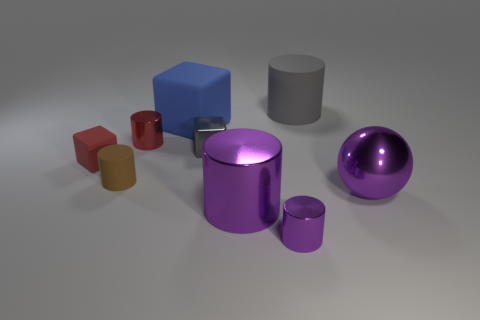There is a big shiny thing that is the same color as the large metallic cylinder; what shape is it?
Keep it short and to the point. Sphere. There is a ball that is the same color as the large shiny cylinder; what size is it?
Your answer should be compact. Large. What number of rubber things have the same color as the large sphere?
Ensure brevity in your answer.  0. There is a purple thing that is the same size as the gray metallic thing; what is its material?
Your answer should be compact. Metal. Are there any big gray rubber cylinders that are left of the block on the left side of the large blue object?
Ensure brevity in your answer.  No. What number of other things are the same color as the big cube?
Your answer should be compact. 0. How big is the gray matte cylinder?
Ensure brevity in your answer.  Large. Are there any big cyan matte things?
Your answer should be compact. No. Are there more things left of the big blue cube than large blue things left of the gray cube?
Your answer should be compact. Yes. What is the material of the thing that is both to the left of the tiny gray object and in front of the tiny rubber cube?
Your answer should be very brief. Rubber. 